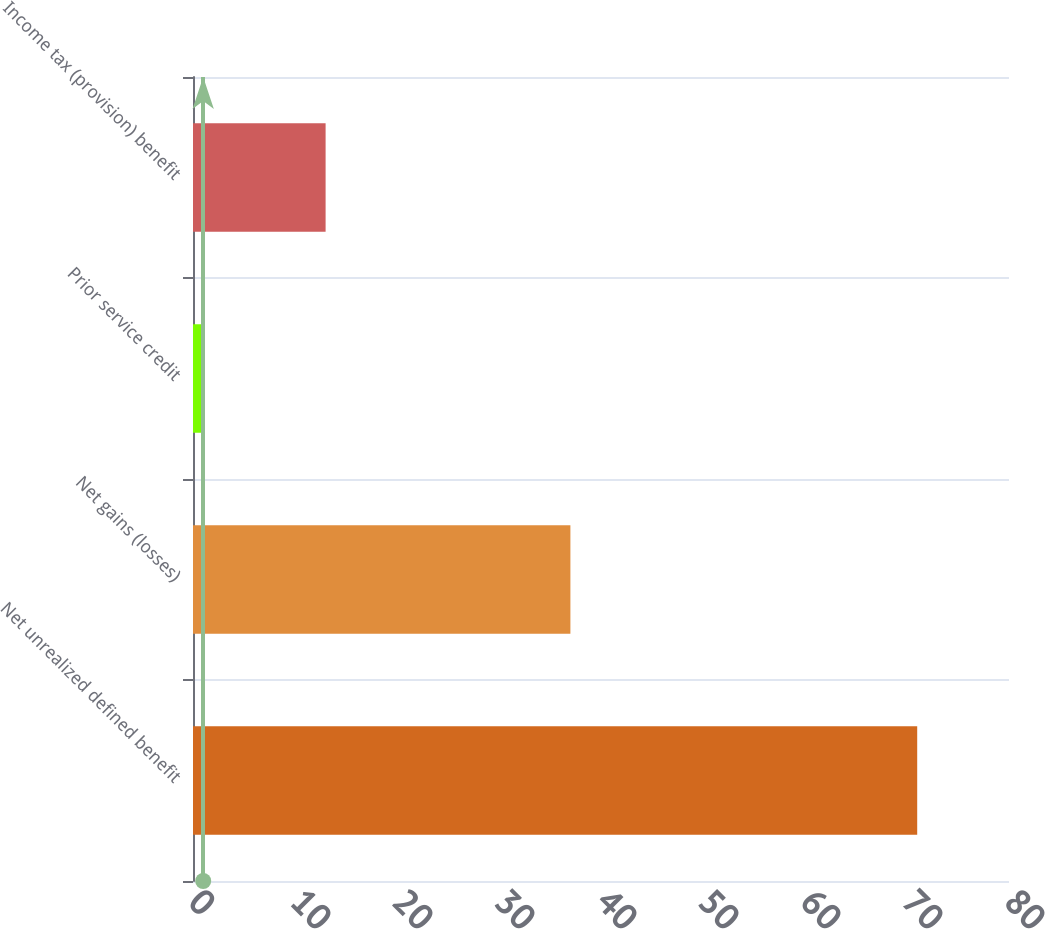Convert chart. <chart><loc_0><loc_0><loc_500><loc_500><bar_chart><fcel>Net unrealized defined benefit<fcel>Net gains (losses)<fcel>Prior service credit<fcel>Income tax (provision) benefit<nl><fcel>71<fcel>37<fcel>1<fcel>13<nl></chart> 